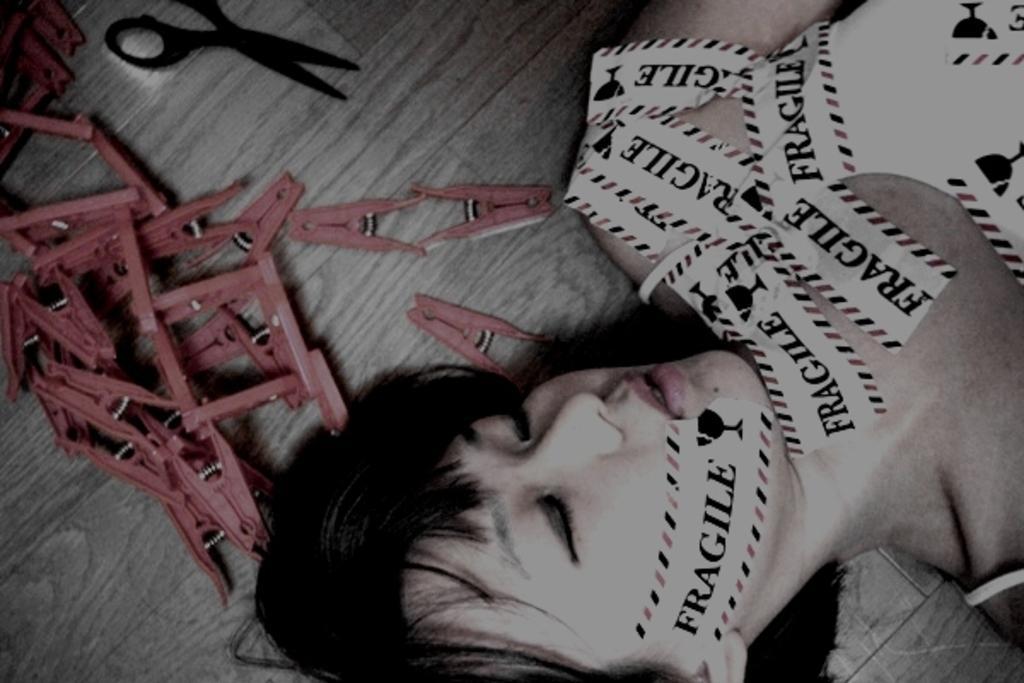Can you describe this image briefly? In this picture there is a woman who is lying on the floor. She is covering his body with papers. Beside her we can see scissor and many cloth holders. 